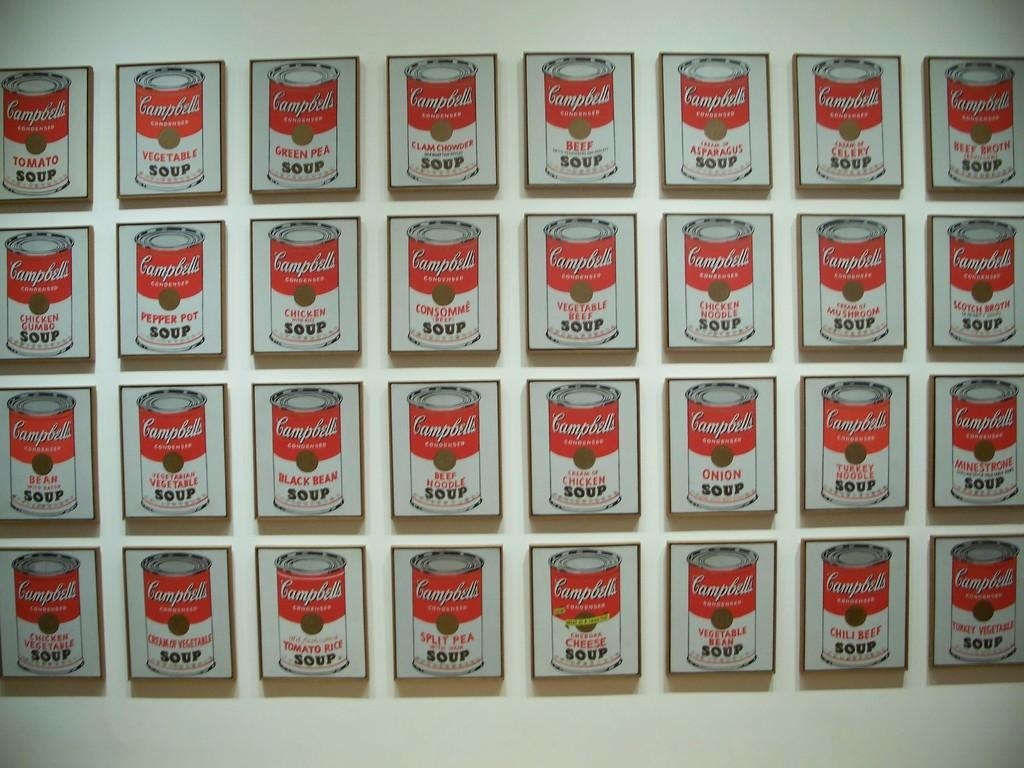<image>
Give a short and clear explanation of the subsequent image. Several paintings of Campbell's condensed soup are on a wall, in different flavors like beef and clam chowder. 